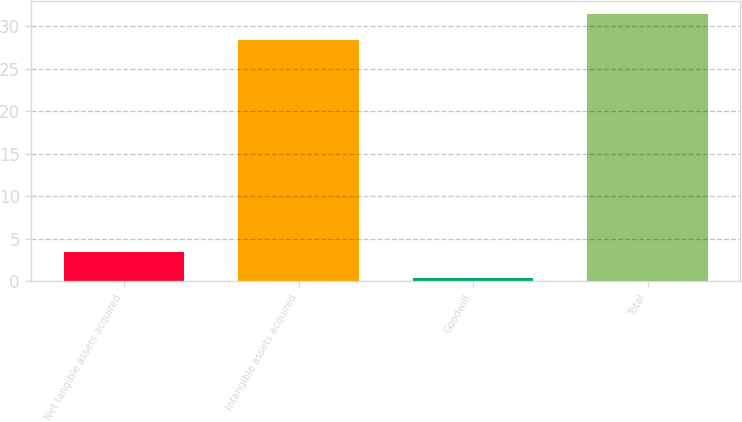<chart> <loc_0><loc_0><loc_500><loc_500><bar_chart><fcel>Net tangible assets acquired<fcel>Intangible assets acquired<fcel>Goodwill<fcel>Total<nl><fcel>3.41<fcel>28.4<fcel>0.4<fcel>31.41<nl></chart> 